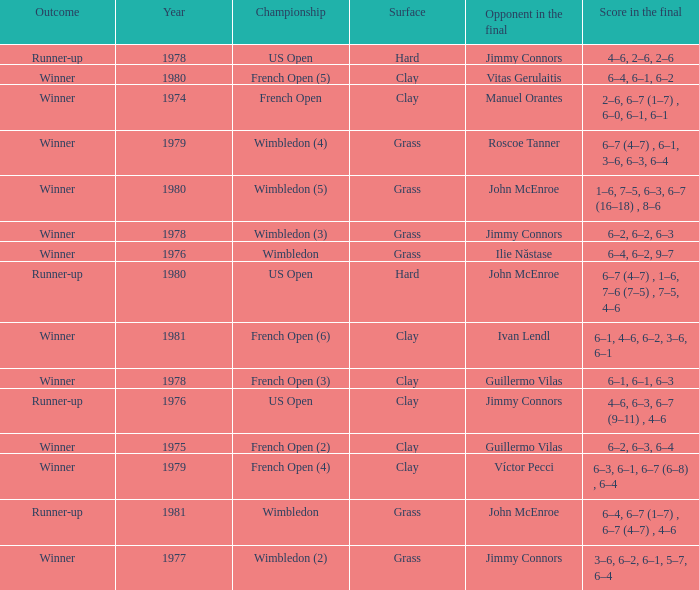What is every surface with a score in the final of 6–4, 6–7 (1–7) , 6–7 (4–7) , 4–6? Grass. 